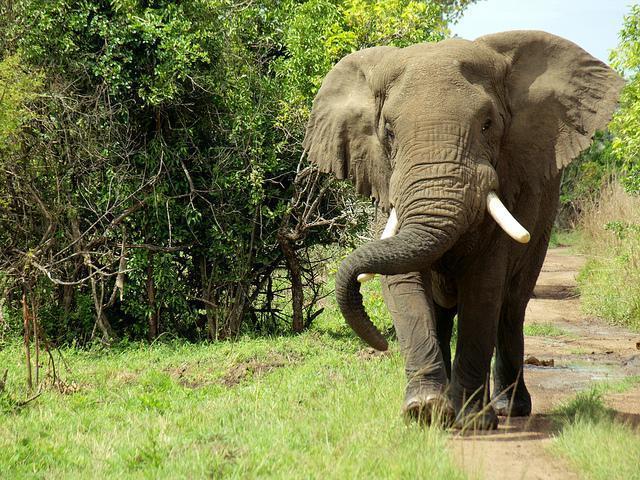How many tusks does the elephant have?
Give a very brief answer. 2. How many grey cars are there in the image?
Give a very brief answer. 0. 